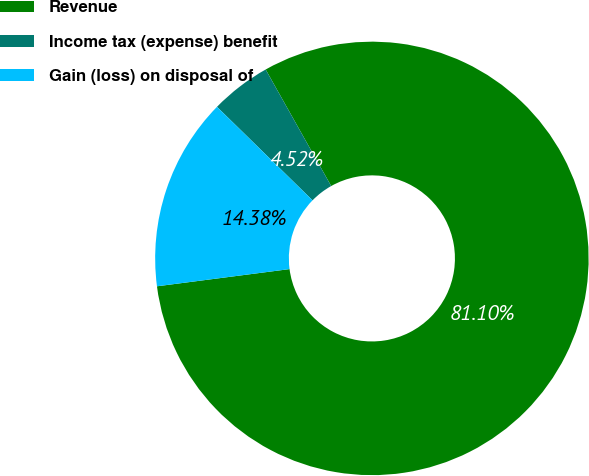<chart> <loc_0><loc_0><loc_500><loc_500><pie_chart><fcel>Revenue<fcel>Income tax (expense) benefit<fcel>Gain (loss) on disposal of<nl><fcel>81.1%<fcel>4.52%<fcel>14.38%<nl></chart> 